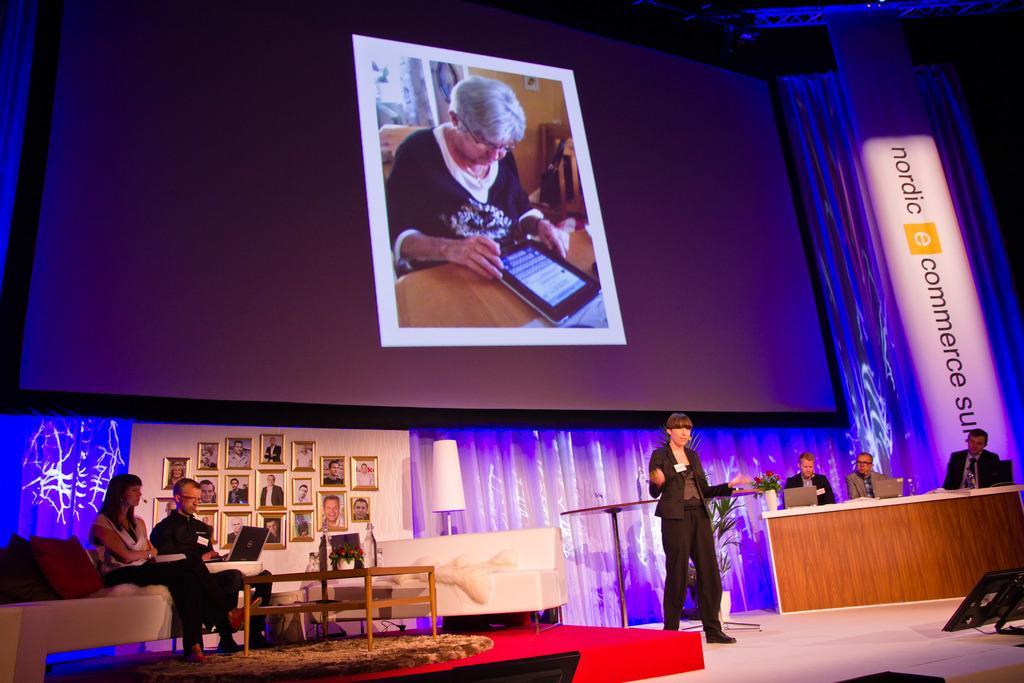How would you summarize this image in a sentence or two? In this picture there is a projector screen in the center of the image and there are people on the right and left side of the image, there is a lady on the right side of the image on the stage and there are photos on the left side of the image. 